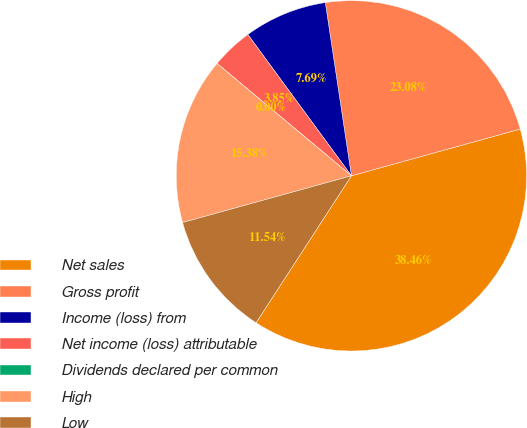<chart> <loc_0><loc_0><loc_500><loc_500><pie_chart><fcel>Net sales<fcel>Gross profit<fcel>Income (loss) from<fcel>Net income (loss) attributable<fcel>Dividends declared per common<fcel>High<fcel>Low<nl><fcel>38.46%<fcel>23.08%<fcel>7.69%<fcel>3.85%<fcel>0.0%<fcel>15.38%<fcel>11.54%<nl></chart> 